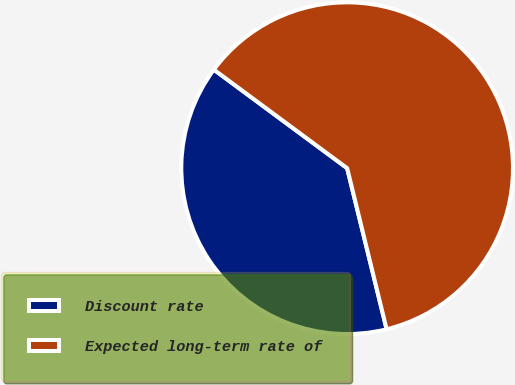Convert chart to OTSL. <chart><loc_0><loc_0><loc_500><loc_500><pie_chart><fcel>Discount rate<fcel>Expected long-term rate of<nl><fcel>38.96%<fcel>61.04%<nl></chart> 